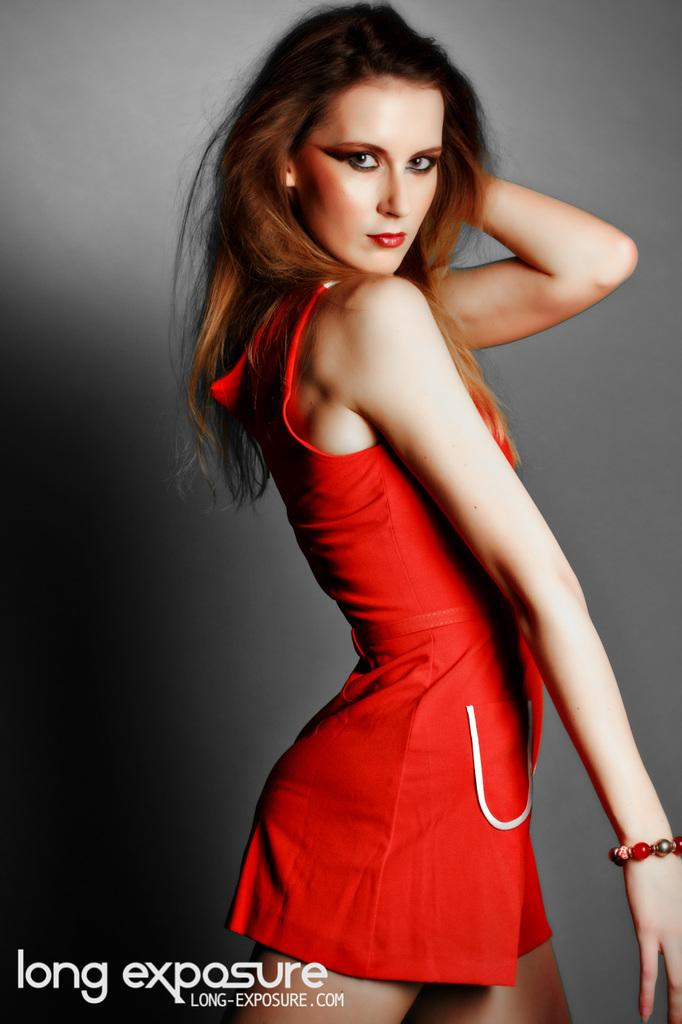<image>
Describe the image concisely. Long-exposure.com's advertisement featuring a female in a red dress. 